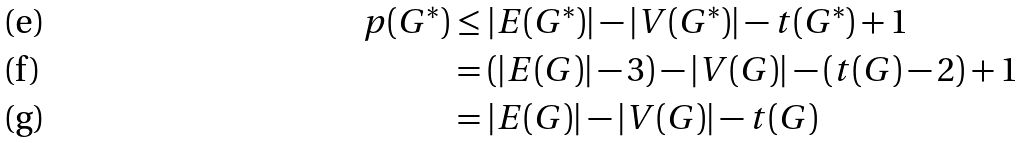Convert formula to latex. <formula><loc_0><loc_0><loc_500><loc_500>p ( G ^ { * } ) & \leq | E ( G ^ { * } ) | - | V ( G ^ { * } ) | - t ( G ^ { * } ) + 1 \\ & = ( | E ( G ) | - 3 ) - | V ( G ) | - ( t ( G ) - 2 ) + 1 \\ & = | E ( G ) | - | V ( G ) | - t ( G )</formula> 